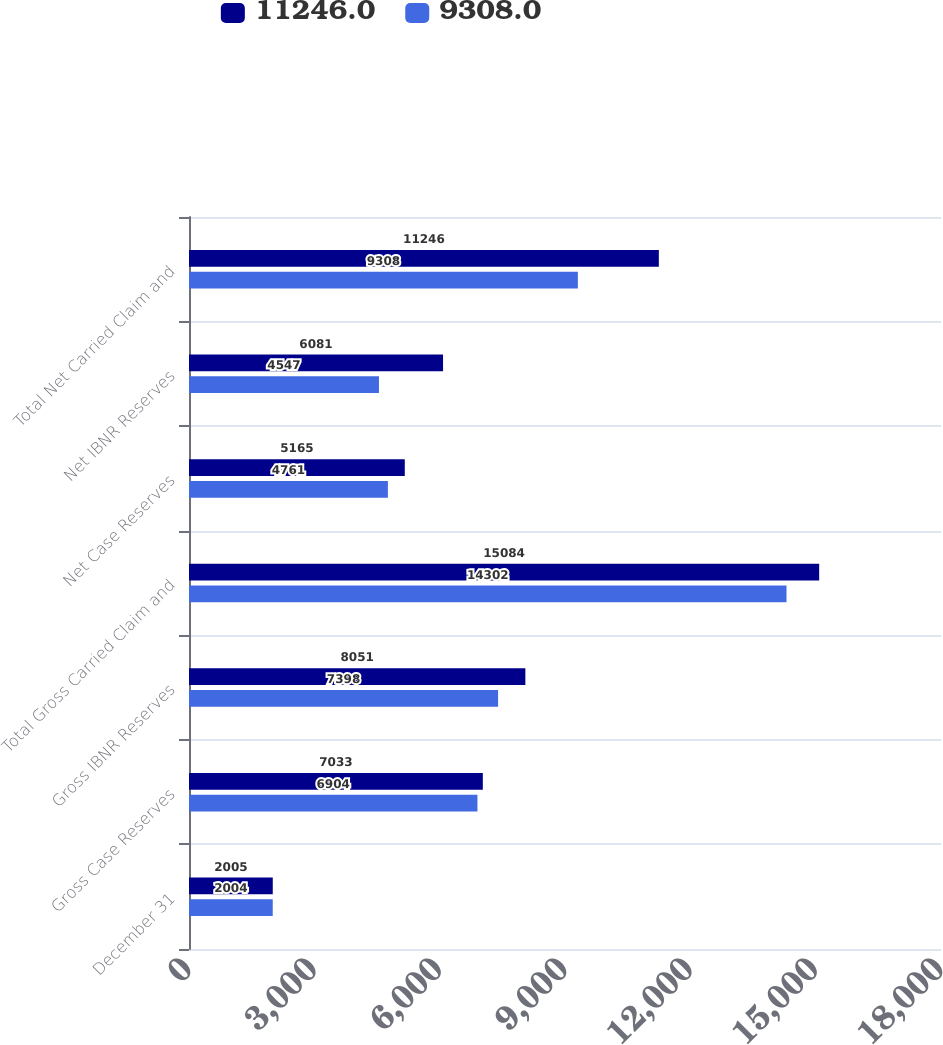Convert chart to OTSL. <chart><loc_0><loc_0><loc_500><loc_500><stacked_bar_chart><ecel><fcel>December 31<fcel>Gross Case Reserves<fcel>Gross IBNR Reserves<fcel>Total Gross Carried Claim and<fcel>Net Case Reserves<fcel>Net IBNR Reserves<fcel>Total Net Carried Claim and<nl><fcel>11246<fcel>2005<fcel>7033<fcel>8051<fcel>15084<fcel>5165<fcel>6081<fcel>11246<nl><fcel>9308<fcel>2004<fcel>6904<fcel>7398<fcel>14302<fcel>4761<fcel>4547<fcel>9308<nl></chart> 